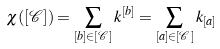<formula> <loc_0><loc_0><loc_500><loc_500>\chi ( [ \mathcal { C } ] ) = \sum _ { [ b ] \in [ \mathcal { C } ] } k ^ { [ b ] } = \sum _ { [ a ] \in [ \mathcal { C } ] } k _ { [ a ] }</formula> 